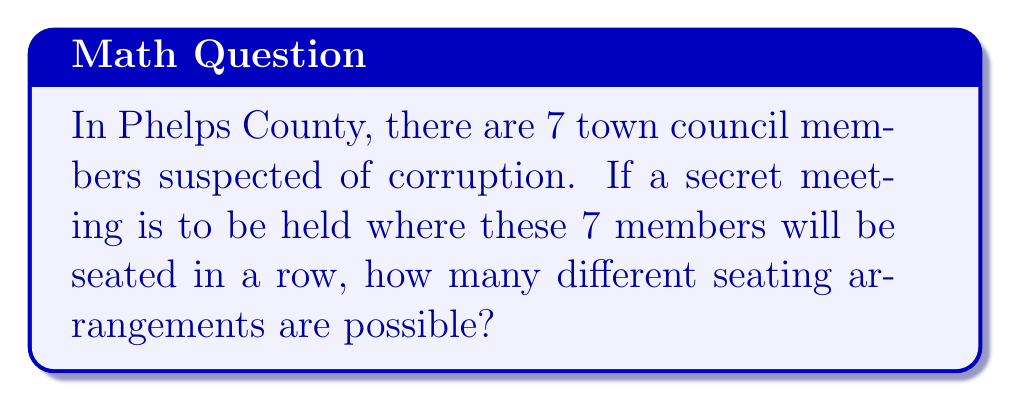Provide a solution to this math problem. Let's approach this step-by-step:

1) This is a permutation problem. We need to arrange 7 distinct people in a specific order.

2) In a permutation, the order matters. Each seating arrangement is considered a different outcome.

3) We have 7 choices for the first seat, 6 for the second, 5 for the third, and so on.

4) This can be represented mathematically as:

   $$7 \times 6 \times 5 \times 4 \times 3 \times 2 \times 1$$

5) This is also known as 7 factorial, written as 7!

6) We can calculate this:
   
   $$7! = 7 \times 6 \times 5 \times 4 \times 3 \times 2 \times 1 = 5040$$

Therefore, there are 5040 different possible seating arrangements for the 7 suspicious town council members.
Answer: $7! = 5040$ 